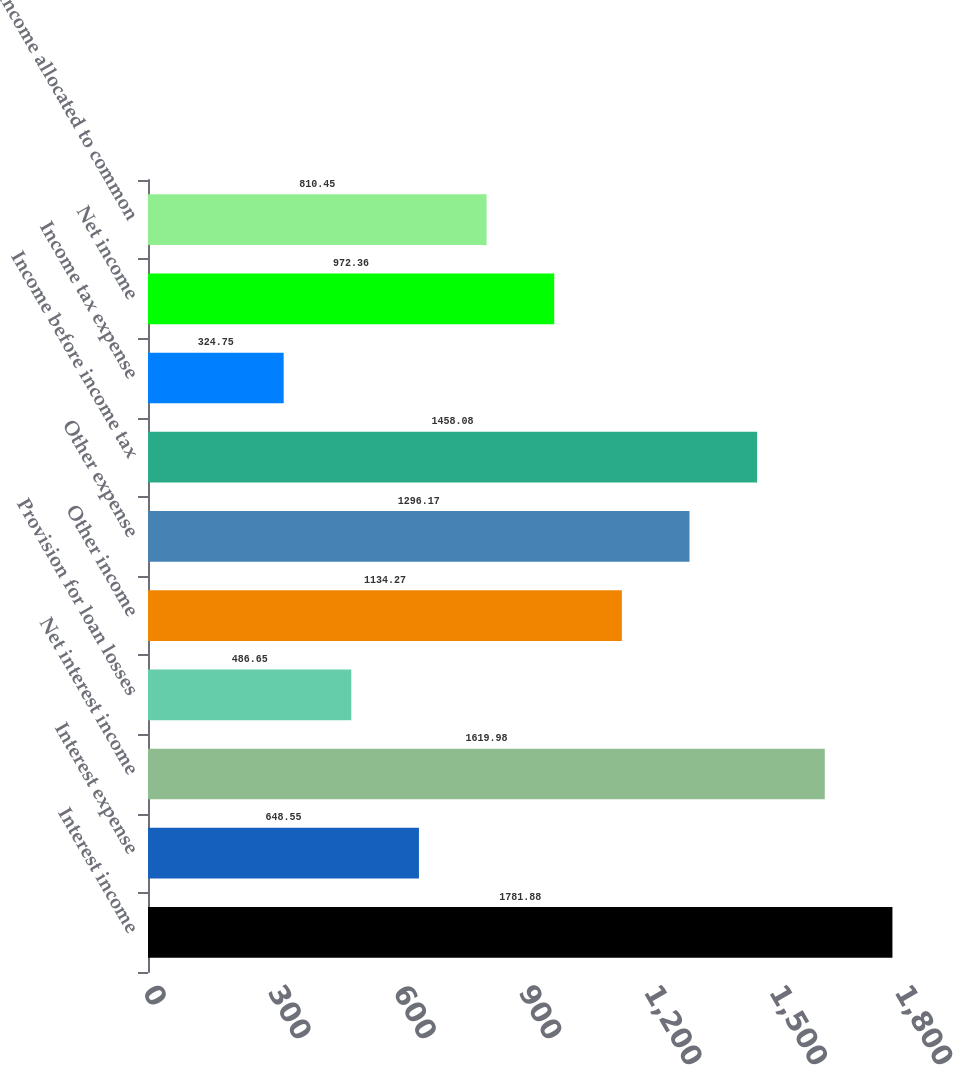Convert chart. <chart><loc_0><loc_0><loc_500><loc_500><bar_chart><fcel>Interest income<fcel>Interest expense<fcel>Net interest income<fcel>Provision for loan losses<fcel>Other income<fcel>Other expense<fcel>Income before income tax<fcel>Income tax expense<fcel>Net income<fcel>Net income allocated to common<nl><fcel>1781.88<fcel>648.55<fcel>1619.98<fcel>486.65<fcel>1134.27<fcel>1296.17<fcel>1458.08<fcel>324.75<fcel>972.36<fcel>810.45<nl></chart> 